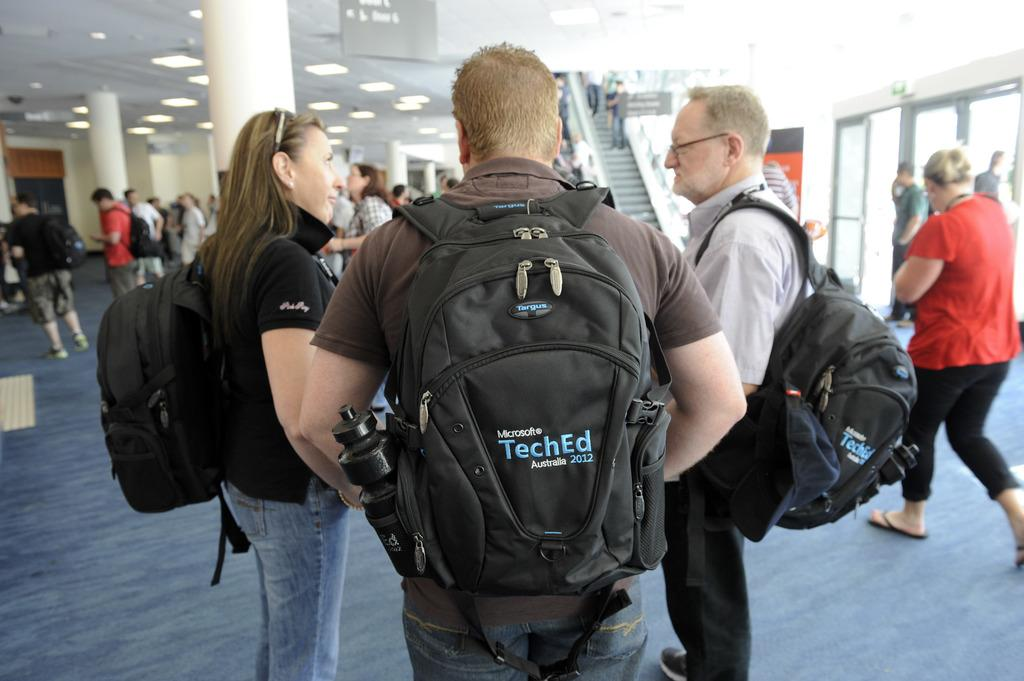<image>
Create a compact narrative representing the image presented. Two men and and a woman wear backpacks from Microsoft TechEd 2012. 